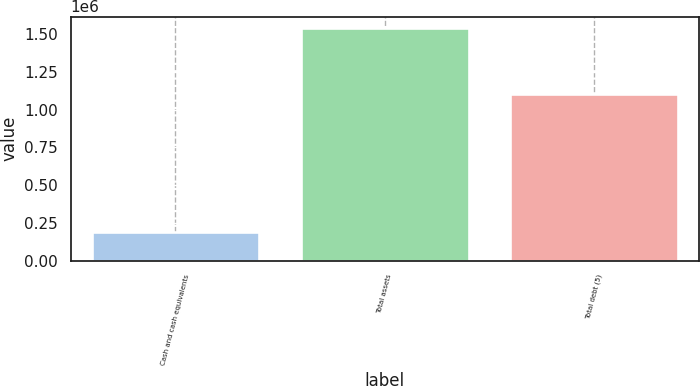Convert chart to OTSL. <chart><loc_0><loc_0><loc_500><loc_500><bar_chart><fcel>Cash and cash equivalents<fcel>Total assets<fcel>Total debt (5)<nl><fcel>191603<fcel>1.54111e+06<fcel>1.10589e+06<nl></chart> 